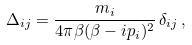Convert formula to latex. <formula><loc_0><loc_0><loc_500><loc_500>\Delta _ { i j } = \frac { m _ { i } } { 4 \pi \beta ( \beta - i p _ { i } ) ^ { 2 } } \, \delta _ { i j } \, ,</formula> 